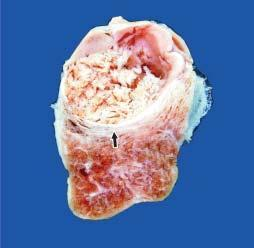what is grey-white soft and shows grossly visible papillary pattern?
Answer the question using a single word or phrase. Nodule 